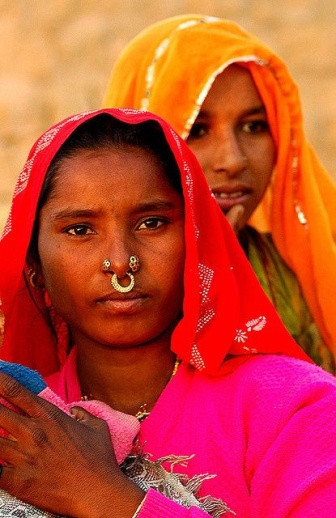If the women in the image could speak, what message do you think they would share with the world? The women would likely share a message of cultural pride and the importance of preserving traditions. They might speak about the strength found in community and heritage, the beauty of their customs, and the stories passed down through generations. They would probably emphasize the richness of their culture and encourage others to honor and celebrate their own histories and identities. 